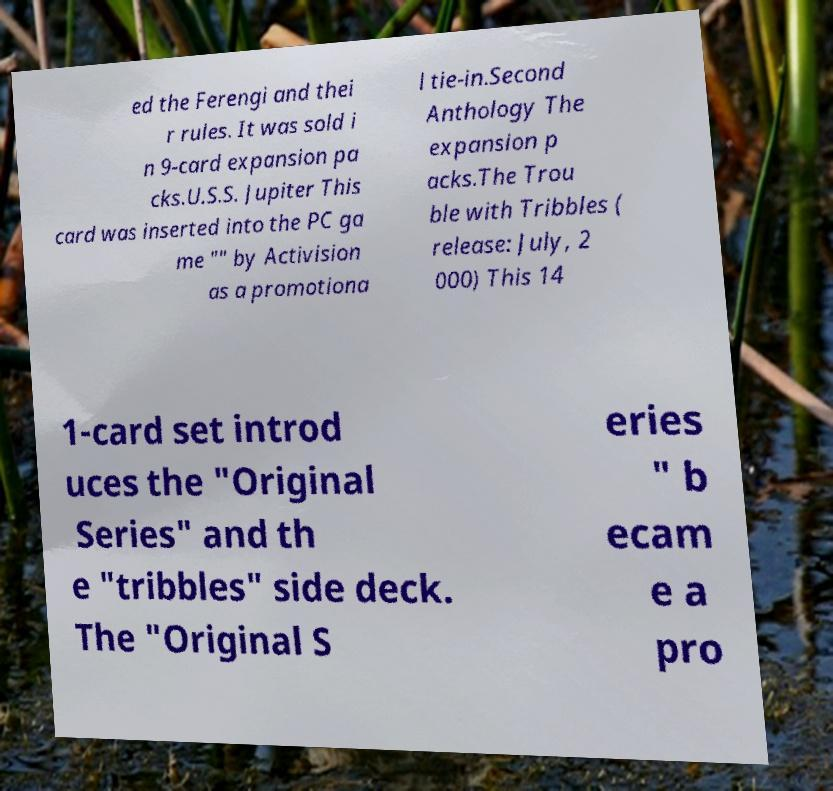Please identify and transcribe the text found in this image. ed the Ferengi and thei r rules. It was sold i n 9-card expansion pa cks.U.S.S. Jupiter This card was inserted into the PC ga me "" by Activision as a promotiona l tie-in.Second Anthology The expansion p acks.The Trou ble with Tribbles ( release: July, 2 000) This 14 1-card set introd uces the "Original Series" and th e "tribbles" side deck. The "Original S eries " b ecam e a pro 